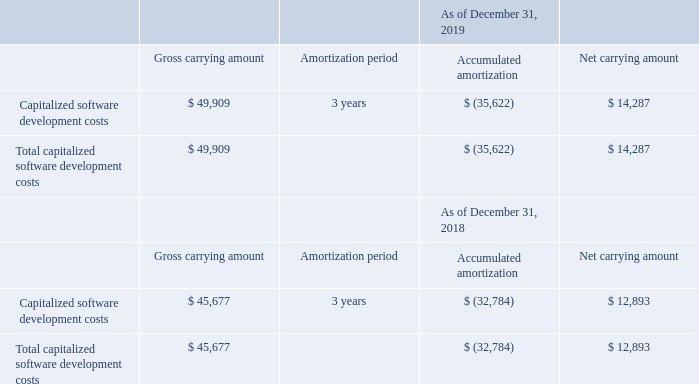Capitalized software development costs consisted of the following (in thousands):
The Company capitalized software development costs of $8.8 million, $8.8 million and $6.2 million during the years ended December 31, 2019, 2018 and 2017, respectively.
Amortized expense for capitalized software development costs was $7.0 million, $5.9 million and $5.0 million during the years ended December 31, 2019, 2018 and 2017, respectively. Amortization of capitalized software development costs is classified within cost of revenue in the consolidated statements of operations and comprehensive loss. During the year ended December 31, 2019, the Company retired $4.6 million of fully amortized capitalized software development costs.
What was the company capitalized software development costs during the years ended December 31, 2019? $8.8 million. What was the company capitalized software development costs during the years ended December 31, 2018? $8.8 million. What was the company capitalized software development costs during the years ended December 31, 2017? $6.2 million. What is the increase/ (decrease) in Gross carrying amount: Capitalized software development costs from December 31, 2019 to December 31, 2018?
Answer scale should be: thousand. 49,909-45,677
Answer: 4232. What is the increase/ (decrease) in Accumulated amortization: Capitalized software development costs from December 31, 2019 to December 31, 2018?
Answer scale should be: thousand. 35,622-32,784
Answer: 2838. What is the increase/ (decrease) in Net carrying amount: Capitalized software development costs from December 31, 2019 to December 31, 2018?
Answer scale should be: thousand. 14,287-12,893
Answer: 1394. 